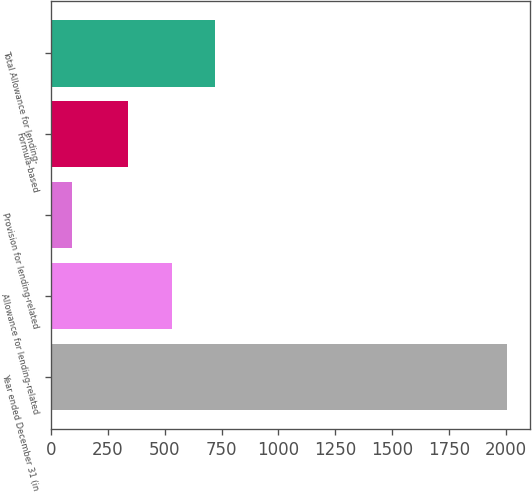Convert chart to OTSL. <chart><loc_0><loc_0><loc_500><loc_500><bar_chart><fcel>Year ended December 31 (in<fcel>Allowance for lending-related<fcel>Provision for lending-related<fcel>Formula-based<fcel>Total Allowance for lending-<nl><fcel>2005<fcel>531.3<fcel>92<fcel>340<fcel>722.6<nl></chart> 